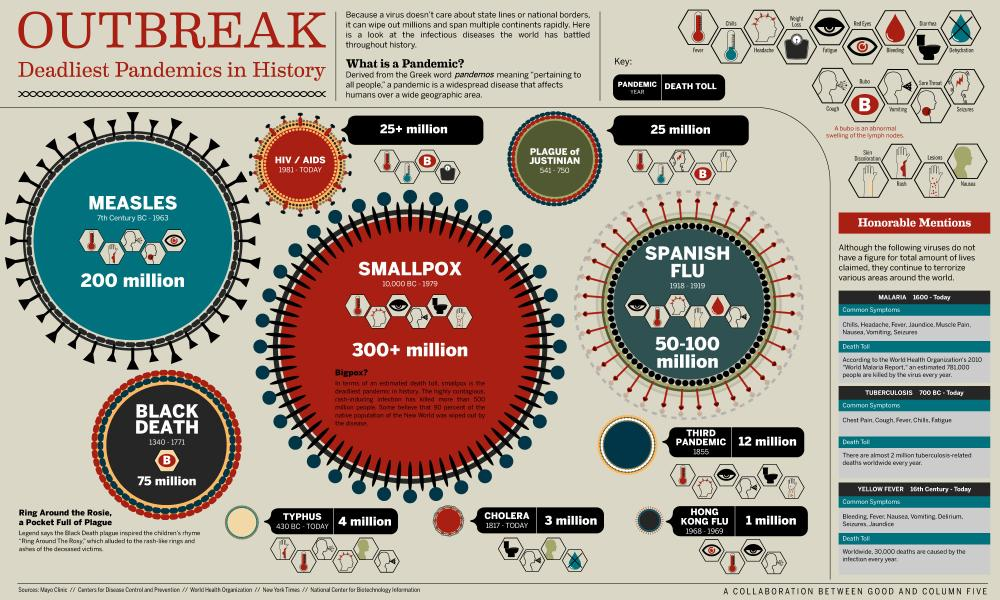Specify some key components in this picture. According to estimates, approximately 200 million people were affected by measles disease worldwide. During the Hong Kong Flu pandemic, an estimated 1 million people worldwide lost their lives. The third plague pandemic began in 1855. The Spanish flu pandemic occurred between 1918 and 1919. Smallpox affected a significant number of people, with estimates indicating that over 300 million individuals were affected by the disease. 